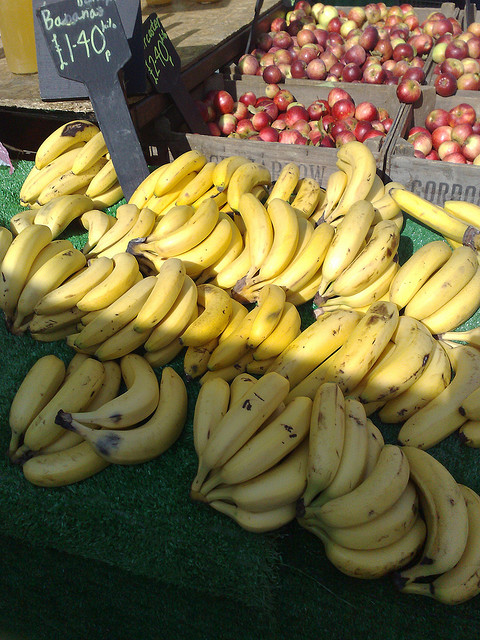Can you tell me what kind of bananas these are? The bananas in the image appear to be of a common variety, often referred to as Cavendish bananas, which are the most widely consumed type of banana around the world. They look perfectly ripe for eating with just a few brown spots. How can I tell when bananas are ripe? Bananas are considered ripe when their skin is bright yellow with small brown spots. These spots develop as the banana's starch converts to sugar, making them sweeter and softer. Overripe bananas may have more prominent brown areas and can be used for baking or smoothies. 